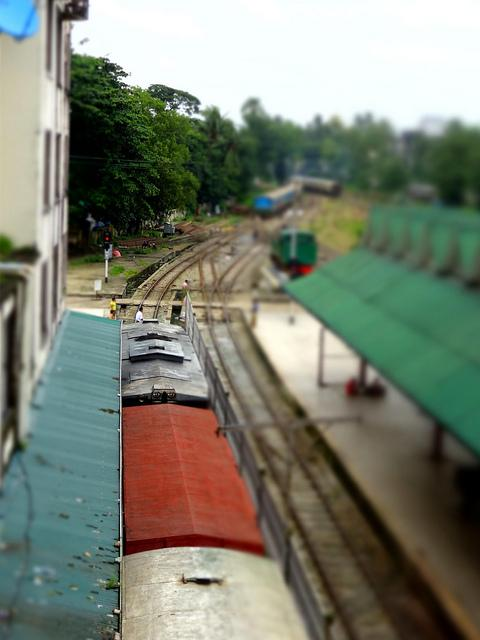What color is the train car in the center of the three cars? red 